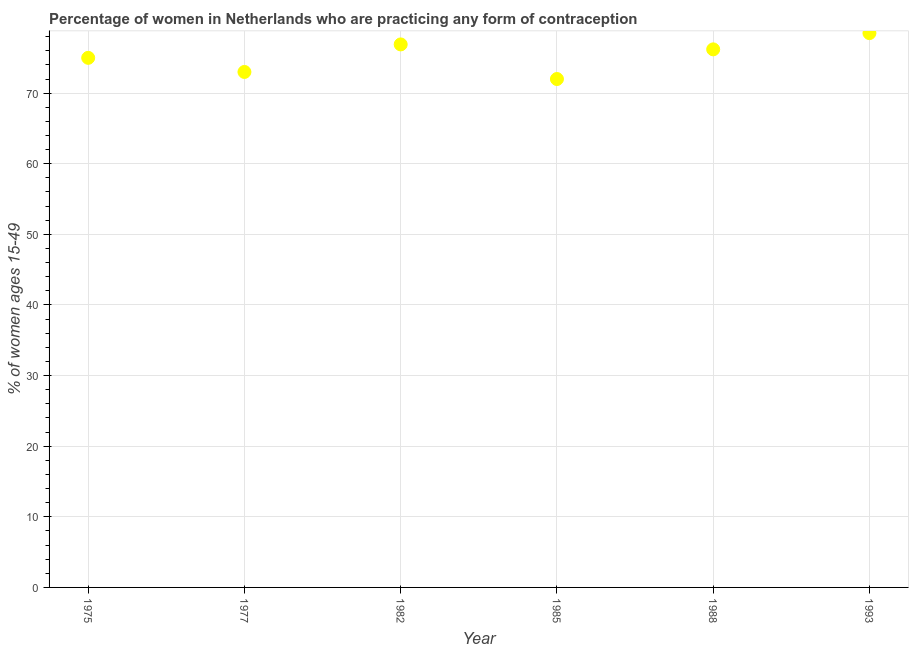Across all years, what is the maximum contraceptive prevalence?
Offer a terse response. 78.5. In which year was the contraceptive prevalence minimum?
Make the answer very short. 1985. What is the sum of the contraceptive prevalence?
Provide a succinct answer. 451.6. What is the difference between the contraceptive prevalence in 1985 and 1988?
Provide a short and direct response. -4.2. What is the average contraceptive prevalence per year?
Your answer should be compact. 75.27. What is the median contraceptive prevalence?
Your response must be concise. 75.6. In how many years, is the contraceptive prevalence greater than 2 %?
Your answer should be compact. 6. Do a majority of the years between 1982 and 1988 (inclusive) have contraceptive prevalence greater than 68 %?
Keep it short and to the point. Yes. What is the ratio of the contraceptive prevalence in 1977 to that in 1985?
Provide a short and direct response. 1.01. Is the contraceptive prevalence in 1988 less than that in 1993?
Your response must be concise. Yes. What is the difference between the highest and the second highest contraceptive prevalence?
Your response must be concise. 1.6. Is the sum of the contraceptive prevalence in 1975 and 1988 greater than the maximum contraceptive prevalence across all years?
Ensure brevity in your answer.  Yes. What is the difference between the highest and the lowest contraceptive prevalence?
Give a very brief answer. 6.5. In how many years, is the contraceptive prevalence greater than the average contraceptive prevalence taken over all years?
Ensure brevity in your answer.  3. Does the contraceptive prevalence monotonically increase over the years?
Provide a succinct answer. No. How many years are there in the graph?
Make the answer very short. 6. Are the values on the major ticks of Y-axis written in scientific E-notation?
Offer a terse response. No. What is the title of the graph?
Your answer should be very brief. Percentage of women in Netherlands who are practicing any form of contraception. What is the label or title of the Y-axis?
Ensure brevity in your answer.  % of women ages 15-49. What is the % of women ages 15-49 in 1975?
Offer a terse response. 75. What is the % of women ages 15-49 in 1977?
Offer a very short reply. 73. What is the % of women ages 15-49 in 1982?
Your answer should be compact. 76.9. What is the % of women ages 15-49 in 1988?
Keep it short and to the point. 76.2. What is the % of women ages 15-49 in 1993?
Keep it short and to the point. 78.5. What is the difference between the % of women ages 15-49 in 1975 and 1982?
Offer a very short reply. -1.9. What is the difference between the % of women ages 15-49 in 1975 and 1985?
Offer a very short reply. 3. What is the difference between the % of women ages 15-49 in 1975 and 1988?
Your response must be concise. -1.2. What is the difference between the % of women ages 15-49 in 1975 and 1993?
Provide a short and direct response. -3.5. What is the difference between the % of women ages 15-49 in 1977 and 1993?
Make the answer very short. -5.5. What is the difference between the % of women ages 15-49 in 1982 and 1985?
Ensure brevity in your answer.  4.9. What is the difference between the % of women ages 15-49 in 1982 and 1988?
Provide a succinct answer. 0.7. What is the difference between the % of women ages 15-49 in 1982 and 1993?
Offer a terse response. -1.6. What is the difference between the % of women ages 15-49 in 1985 and 1988?
Provide a succinct answer. -4.2. What is the difference between the % of women ages 15-49 in 1985 and 1993?
Give a very brief answer. -6.5. What is the ratio of the % of women ages 15-49 in 1975 to that in 1977?
Ensure brevity in your answer.  1.03. What is the ratio of the % of women ages 15-49 in 1975 to that in 1985?
Your response must be concise. 1.04. What is the ratio of the % of women ages 15-49 in 1975 to that in 1993?
Keep it short and to the point. 0.95. What is the ratio of the % of women ages 15-49 in 1977 to that in 1982?
Make the answer very short. 0.95. What is the ratio of the % of women ages 15-49 in 1977 to that in 1985?
Ensure brevity in your answer.  1.01. What is the ratio of the % of women ages 15-49 in 1977 to that in 1988?
Your answer should be compact. 0.96. What is the ratio of the % of women ages 15-49 in 1982 to that in 1985?
Make the answer very short. 1.07. What is the ratio of the % of women ages 15-49 in 1985 to that in 1988?
Your answer should be very brief. 0.94. What is the ratio of the % of women ages 15-49 in 1985 to that in 1993?
Make the answer very short. 0.92. 